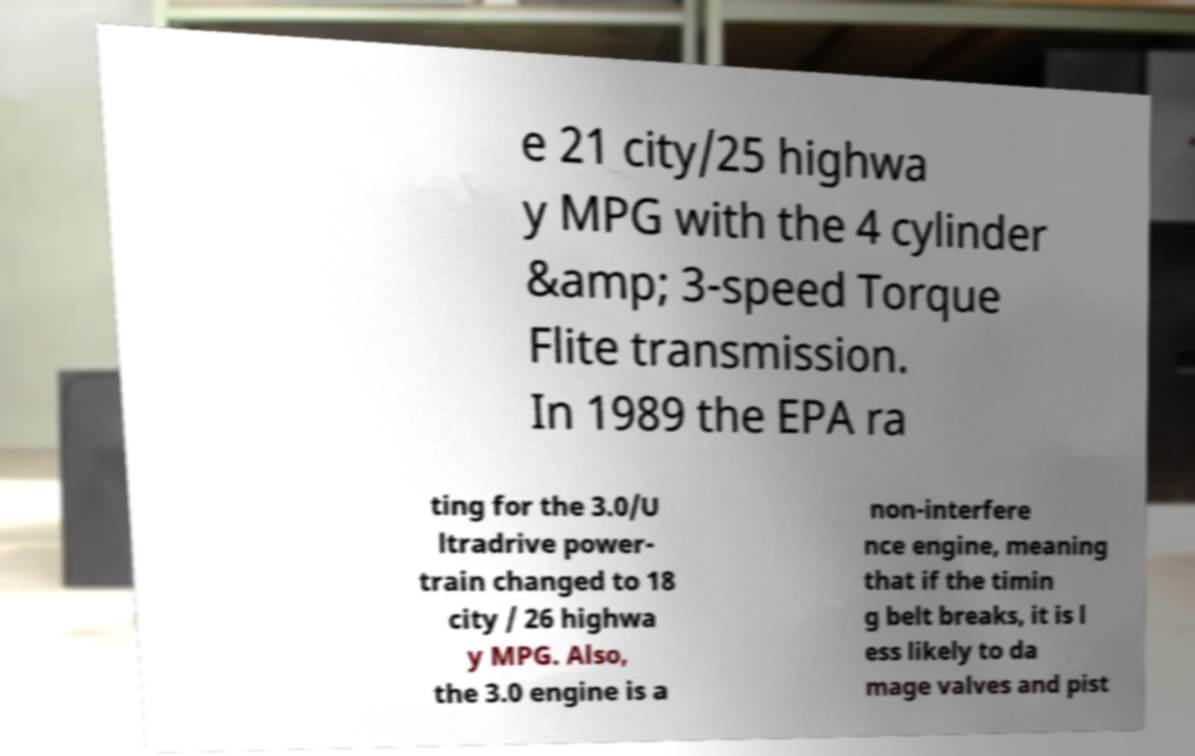Could you extract and type out the text from this image? e 21 city/25 highwa y MPG with the 4 cylinder &amp; 3-speed Torque Flite transmission. In 1989 the EPA ra ting for the 3.0/U ltradrive power- train changed to 18 city / 26 highwa y MPG. Also, the 3.0 engine is a non-interfere nce engine, meaning that if the timin g belt breaks, it is l ess likely to da mage valves and pist 